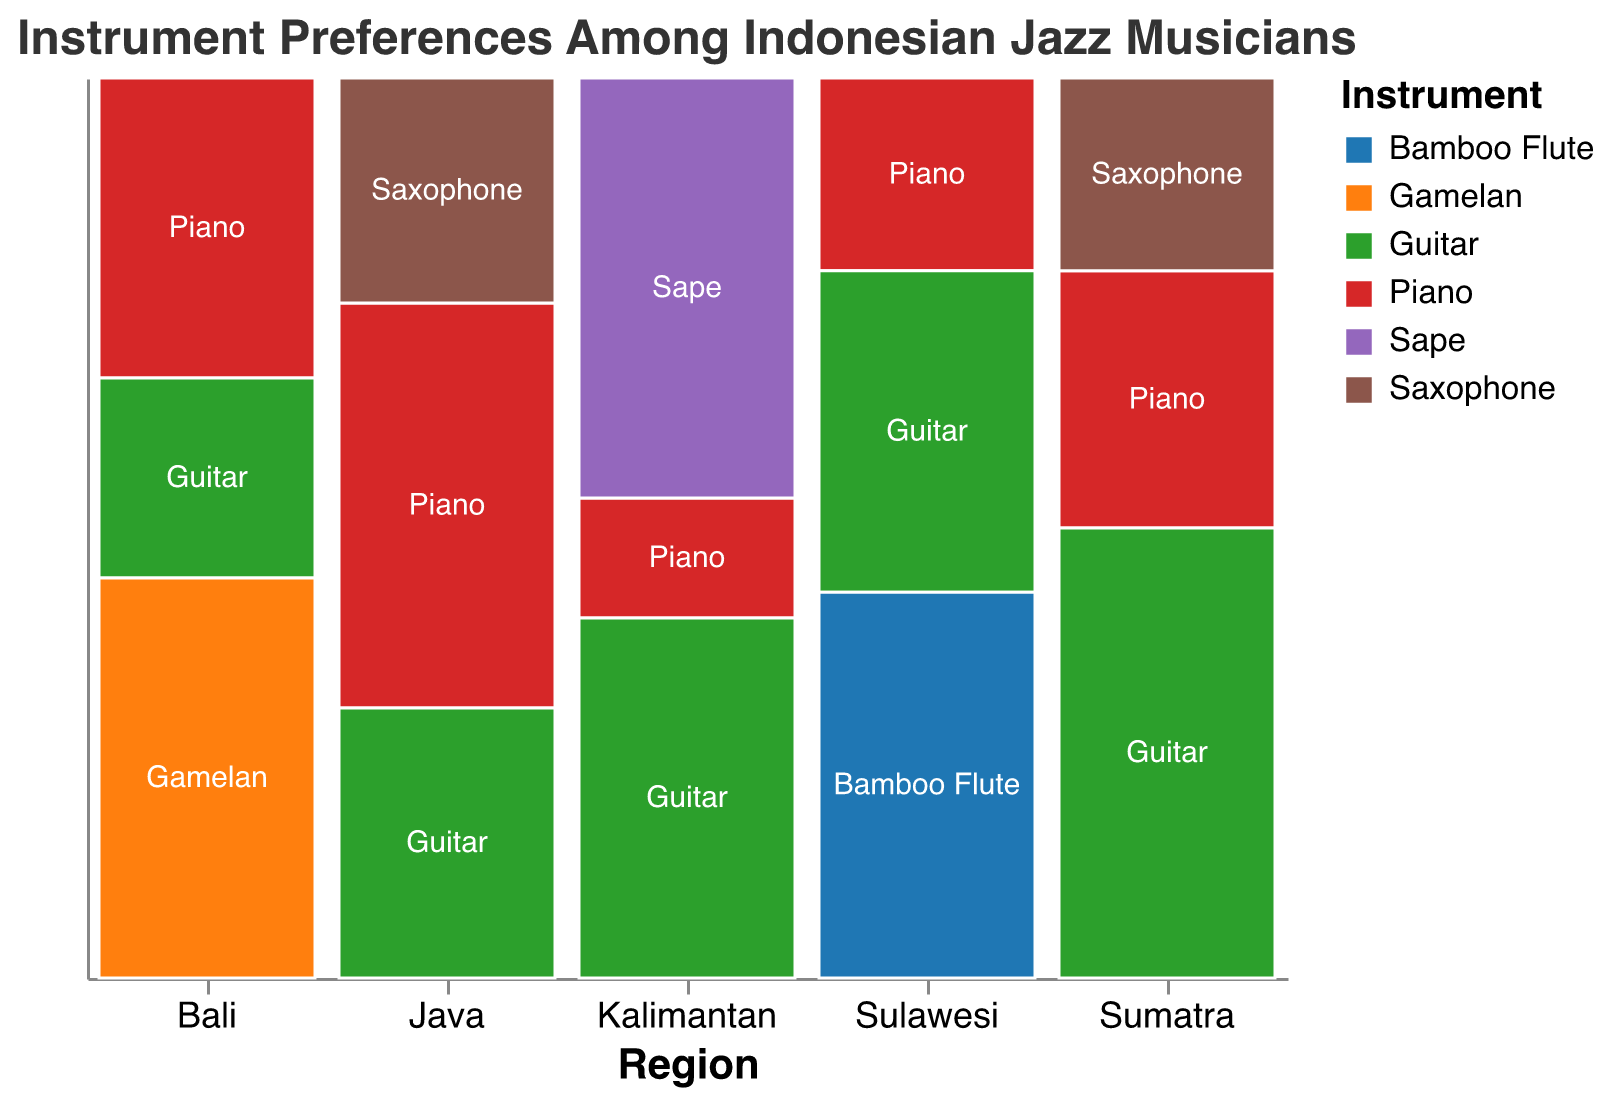Which region has the highest preference for the Piano? The region with the tallest bar segment for Piano will have the highest preference. Java has the tallest bar segment for Piano.
Answer: Java What instrument is most preferred in Bali? Identify the largest colored segment in the Bali region. The Gamelan has the largest segment in Bali.
Answer: Gamelan How many counts are there for Saxophone players in Sumatra? The height of the Saxophone's segment in Sumatra will provide this information. The Saxophone segment in Sumatra is labeled with 15 counts.
Answer: 15 Which region has the highest overall musical instrument preference? Sum the height of all segments for each region; the region with the highest total will be the one with the highest overall preference. Java has the highest total count (100).
Answer: Java Is the preference for Guitar higher in Java or in Kalimantan? Compare the heights of the Guitar segments in Java and Kalimantan. Java has 30 counts, and Kalimantan has 30 counts. They are equal.
Answer: Equal Which region has the most diverse instrument preferences? Look for the region with the most different instruments represented. Sulawesi has the most diverse with Piano, Guitar, and Bamboo Flute.
Answer: Sulawesi What is the least preferred instrument in Java? Identify the shortest segment in Java. The Saxophone segment is the shortest with 25 counts.
Answer: Saxophone Do Piano players dominate the preferences in most regions? Examine if the Piano segment is one of the tallest or a significant portion in most regions. Piano has a significant presence in Java, Bali, but not in Sumatra, Sulawesi, and Kalimantan.
Answer: No In which region is there a preference for traditional instruments? Identify the regions that have traditional instruments and their counts. Bali (Gamelan), Sulawesi (Bamboo Flute), and Kalimantan (Sape) have traditional instruments.
Answer: Bali, Sulawesi, Kalimantan What is the relative preference of the Guitar in Sumatra compared to a traditional instrument in Sulawesi? Compare the Guitar segment in Sumatra to the Bamboo Flute segment in Sulawesi. Guitar in Sumatra has a count of 35, Bamboo Flute in Sulawesi has 30 counts.
Answer: Higher in Sumatra 